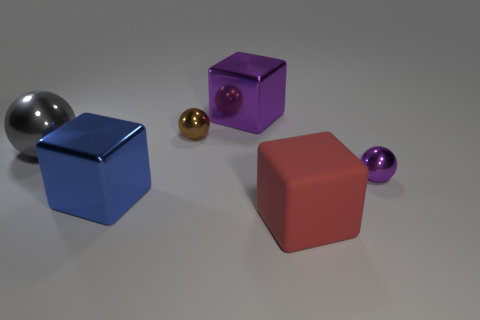Add 2 tiny cyan matte things. How many objects exist? 8 Subtract all large blue shiny objects. Subtract all large blue metal cubes. How many objects are left? 4 Add 6 large red blocks. How many large red blocks are left? 7 Add 5 big metallic things. How many big metallic things exist? 8 Subtract 1 purple cubes. How many objects are left? 5 